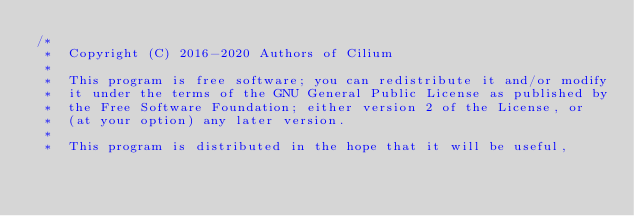<code> <loc_0><loc_0><loc_500><loc_500><_C_>/*
 *  Copyright (C) 2016-2020 Authors of Cilium
 *
 *  This program is free software; you can redistribute it and/or modify
 *  it under the terms of the GNU General Public License as published by
 *  the Free Software Foundation; either version 2 of the License, or
 *  (at your option) any later version.
 *
 *  This program is distributed in the hope that it will be useful,</code> 